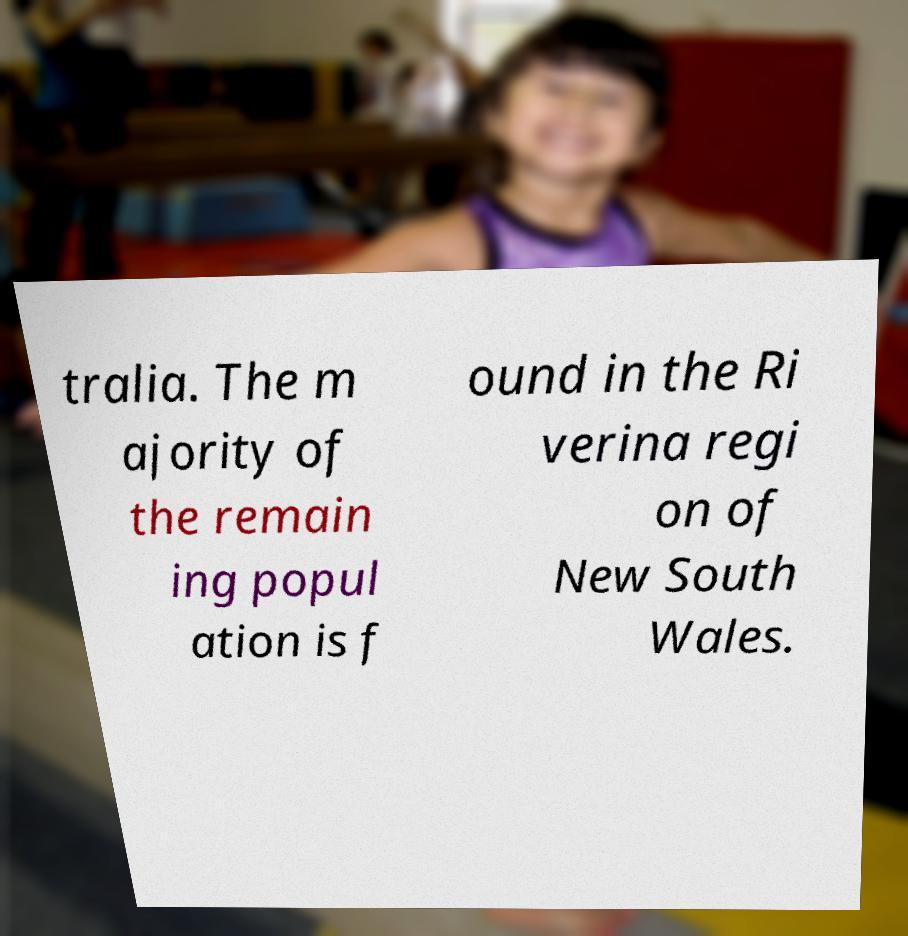I need the written content from this picture converted into text. Can you do that? tralia. The m ajority of the remain ing popul ation is f ound in the Ri verina regi on of New South Wales. 